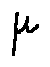<formula> <loc_0><loc_0><loc_500><loc_500>\mu</formula> 